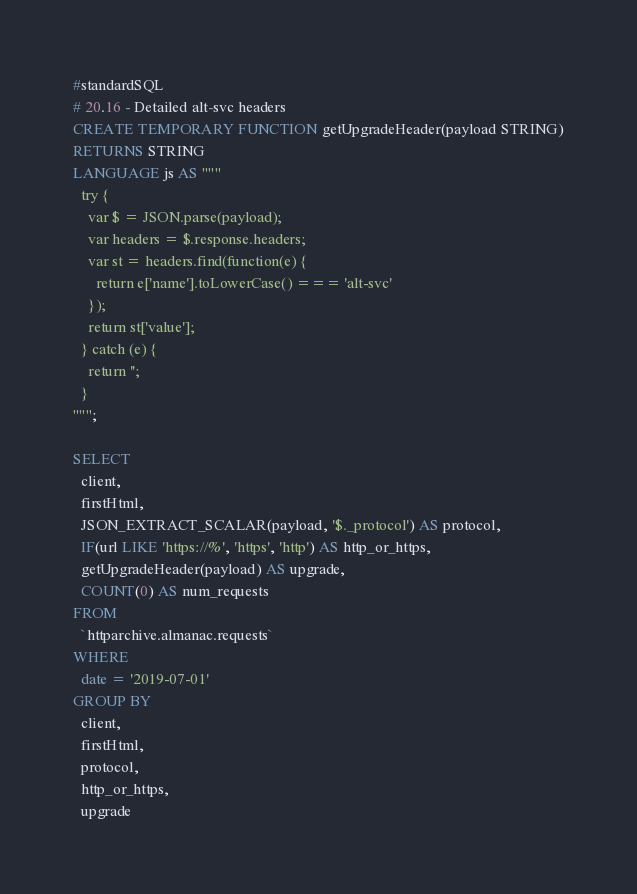<code> <loc_0><loc_0><loc_500><loc_500><_SQL_>#standardSQL
# 20.16 - Detailed alt-svc headers
CREATE TEMPORARY FUNCTION getUpgradeHeader(payload STRING)
RETURNS STRING
LANGUAGE js AS """
  try {
    var $ = JSON.parse(payload);
    var headers = $.response.headers;
    var st = headers.find(function(e) {
      return e['name'].toLowerCase() === 'alt-svc'
    });
    return st['value'];
  } catch (e) {
    return '';
  }
""";

SELECT
  client,
  firstHtml,
  JSON_EXTRACT_SCALAR(payload, '$._protocol') AS protocol,
  IF(url LIKE 'https://%', 'https', 'http') AS http_or_https,
  getUpgradeHeader(payload) AS upgrade,
  COUNT(0) AS num_requests
FROM
  `httparchive.almanac.requests`
WHERE
  date = '2019-07-01'
GROUP BY
  client,
  firstHtml,
  protocol,
  http_or_https,
  upgrade
</code> 